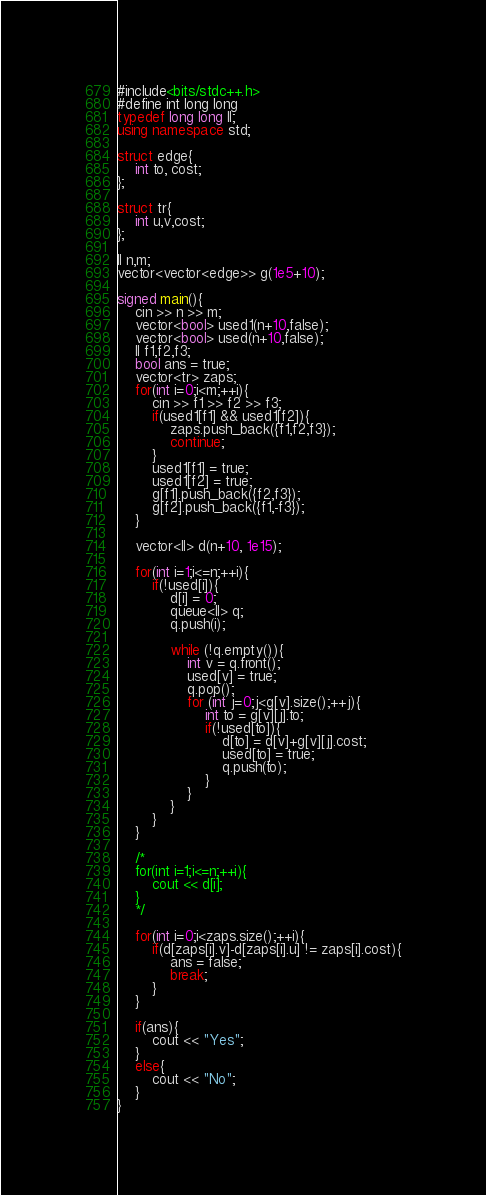<code> <loc_0><loc_0><loc_500><loc_500><_C++_>#include<bits/stdc++.h>
#define int long long
typedef long long ll;
using namespace std;

struct edge{
    int to, cost;
};

struct tr{
    int u,v,cost;
};

ll n,m;
vector<vector<edge>> g(1e5+10);

signed main(){
    cin >> n >> m;
    vector<bool> used1(n+10,false);
    vector<bool> used(n+10,false);
    ll f1,f2,f3;
    bool ans = true;
    vector<tr> zaps;
    for(int i=0;i<m;++i){
        cin >> f1 >> f2 >> f3;
        if(used1[f1] && used1[f2]){
            zaps.push_back({f1,f2,f3});
            continue;
        }
        used1[f1] = true;
        used1[f2] = true;
        g[f1].push_back({f2,f3});
        g[f2].push_back({f1,-f3});
    }

    vector<ll> d(n+10, 1e15);

    for(int i=1;i<=n;++i){
        if(!used[i]){
            d[i] = 0;
            queue<ll> q;
            q.push(i);

            while (!q.empty()){
                int v = q.front();
                used[v] = true;
                q.pop();
                for (int j=0;j<g[v].size();++j){
                    int to = g[v][j].to;
                    if(!used[to]){
                        d[to] = d[v]+g[v][j].cost;
                        used[to] = true;
                        q.push(to);
                    }
                }
            }
        }
    }
    
    /*
    for(int i=1;i<=n;++i){
        cout << d[i];
    }
    */

    for(int i=0;i<zaps.size();++i){
        if(d[zaps[i].v]-d[zaps[i].u] != zaps[i].cost){
            ans = false;
            break;
        }
    }

    if(ans){
        cout << "Yes";
    }
    else{
        cout << "No";
    }
}
</code> 